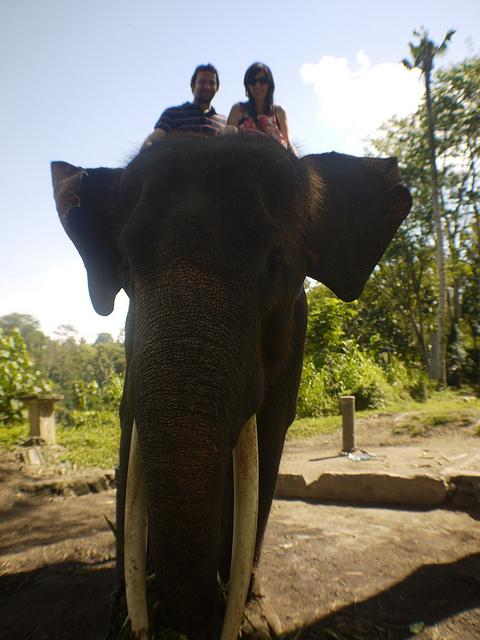Where can you find this animal? Please explain your reasoning. india. Elephants can be found in india. 